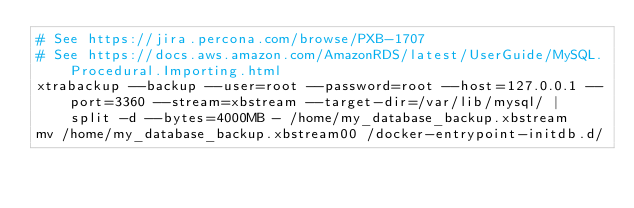<code> <loc_0><loc_0><loc_500><loc_500><_Bash_># See https://jira.percona.com/browse/PXB-1707
# See https://docs.aws.amazon.com/AmazonRDS/latest/UserGuide/MySQL.Procedural.Importing.html
xtrabackup --backup --user=root --password=root --host=127.0.0.1 --port=3360 --stream=xbstream --target-dir=/var/lib/mysql/ | split -d --bytes=4000MB - /home/my_database_backup.xbstream
mv /home/my_database_backup.xbstream00 /docker-entrypoint-initdb.d/</code> 